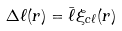<formula> <loc_0><loc_0><loc_500><loc_500>\Delta \ell ( r ) = \bar { \ell } \xi _ { c \ell } ( r )</formula> 